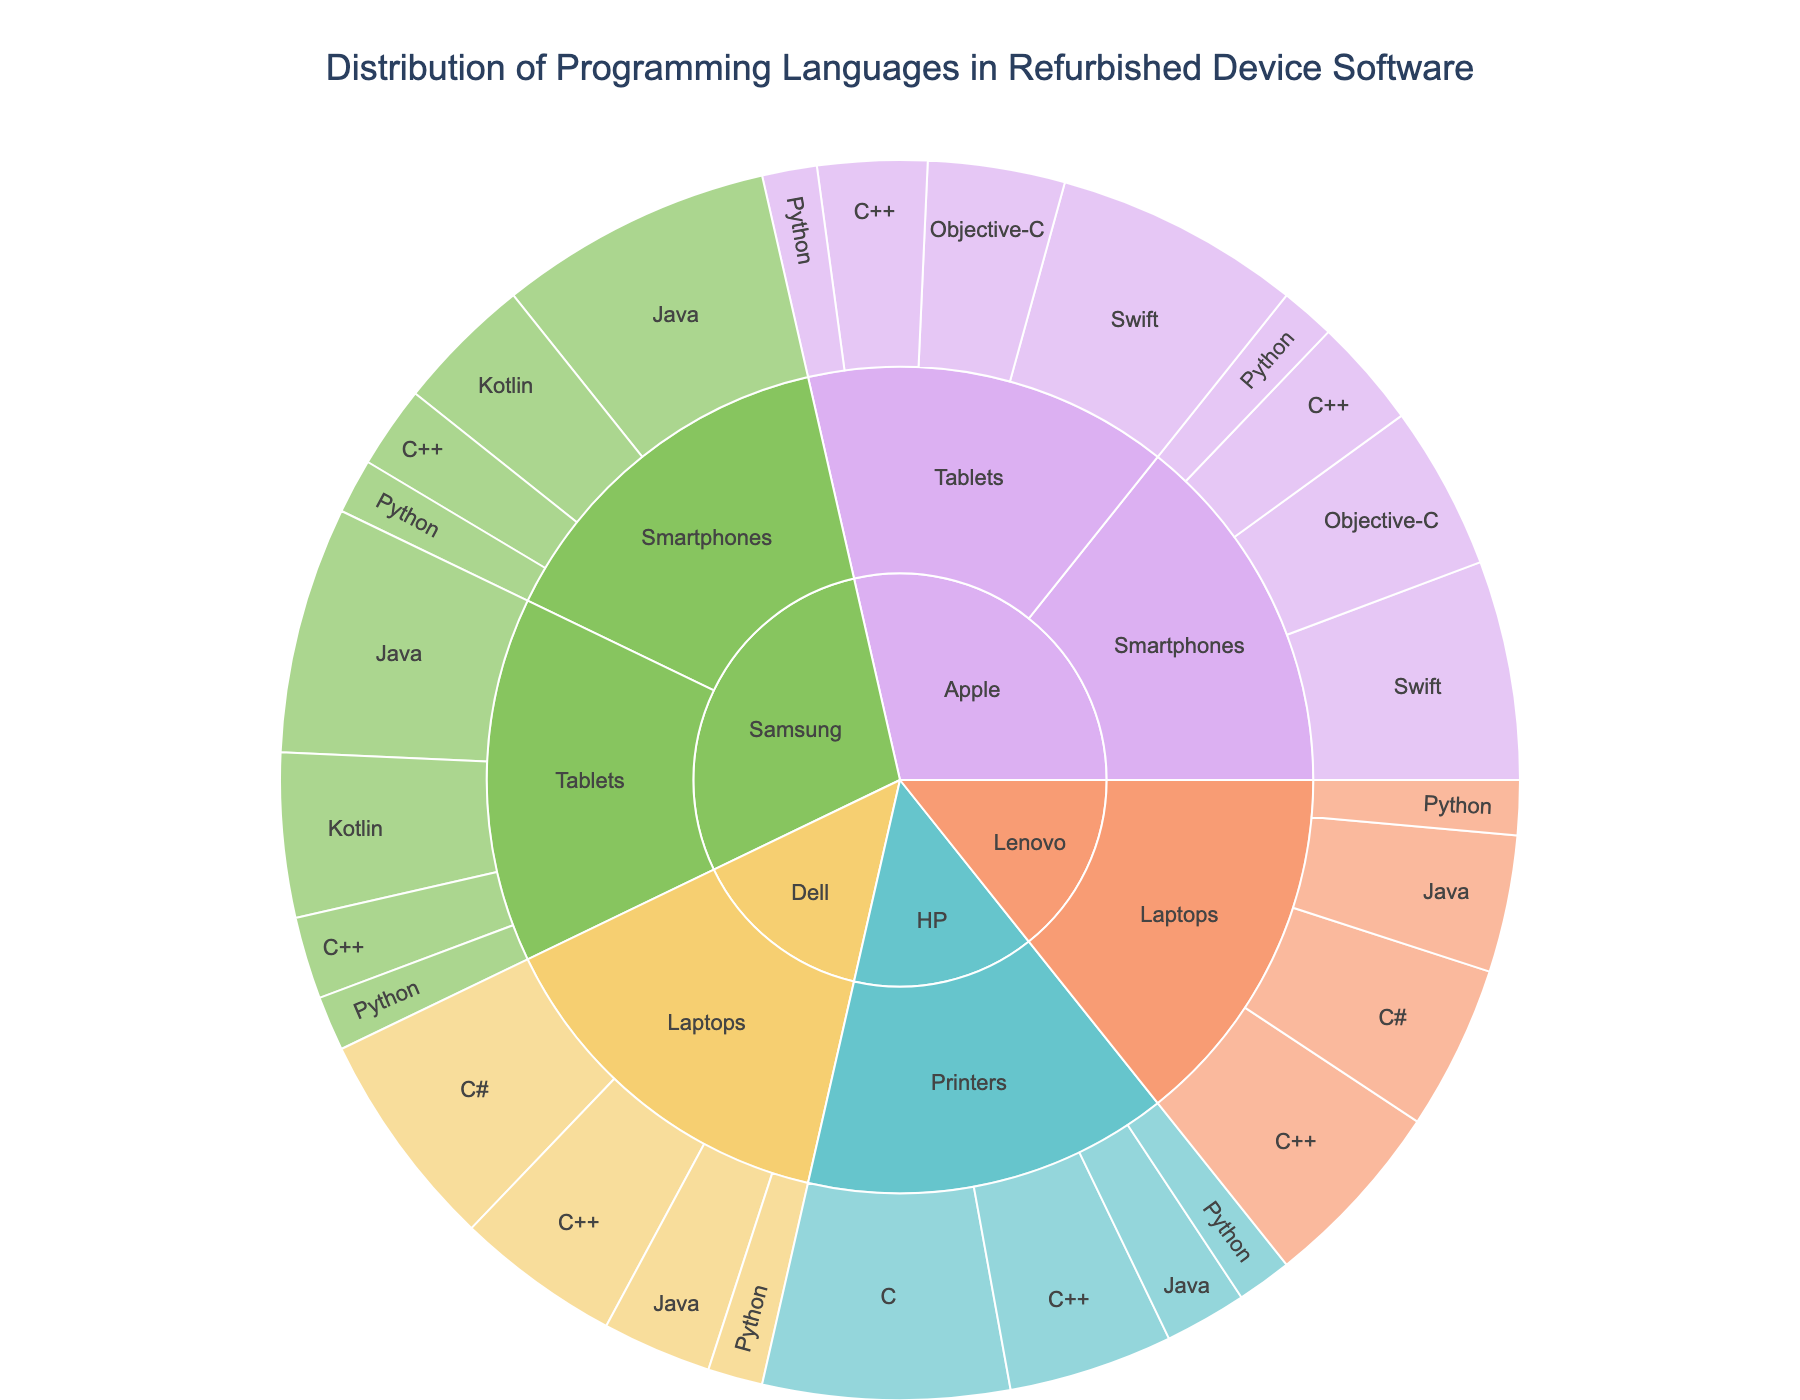What percentage of programming languages used by Apple in smartphones is Python? The first level in the sunburst plot is 'manufacturer', and selecting Apple, then the next level is 'device category'. For smartphones, we look at the 'programming language'. The percentage for Python is 10%.
Answer: 10% Which manufacturer uses Java the most for tablets? Navigate the plot to 'manufacturer' and then to 'device category' for Tablets. Compare the percentages of Java. Samsung uses Java 45% for tablets, which is the highest among all.
Answer: Samsung What is the combined percentage of Kotlin used in Samsung devices (smartphones and tablets)? First, find the percentage of Kotlin for Samsung smartphones (25%) and then for tablets (30%). Add them together: 25% + 30% = 55%.
Answer: 55% How does the usage of Swift in Apple's tablets compare to its smartphones? For Apple, navigate to 'device category'. Swift is 45% in tablets and 40% in smartphones. The usage in tablets (45%) is higher than in smartphones (40%).
Answer: Tablets' Swift usage is higher What's the total percentage of C++ usage in Lenovo laptops? In Lenovo laptops, locate the C++ usage, which is 35%. Since there is no subdivision, this is the total percentage.
Answer: 35% Which programming language is the least used in HP printers? Navigate to HP printers and compare the percentages of the listed languages. Python is used 10%, which is the least compared to others.
Answer: Python What is the most commonly used programming language in Dell laptops? For Dell laptops, check each programming language's percentage. C# is the most used at 40%.
Answer: C# Compare the usage of Objective-C in Apple's tablets to its usage in smartphones. Identify Apple's category sections and find Objective-C in both tablets and smartphones. Tablets have 25% Objective-C while smartphones have 30%. Usage is higher in smartphones.
Answer: Higher in smartphones In which device category does Python have a consistent usage percentage across Apple and Samsung devices? Look at Python percentages across Apple (10% in smartphones, 10% in tablets) and Samsung (10% in smartphones, 10% in tablets). It’s consistently 10% across both companies' smartphones and tablets.
Answer: Smartphones and tablets Summarize the usage trend of C++ across the different manufacturers. Check each manufacturer and their device categories for C++ usage. For Apple (20% in both categories), Samsung (15% in both categories), Dell (30%), Lenovo (35%), and HP (30%). Consistent within companies like Samsung and Apple, moderate usage in Dell and HP, and highest in Lenovo.
Answer: Consistent or moderate usage 